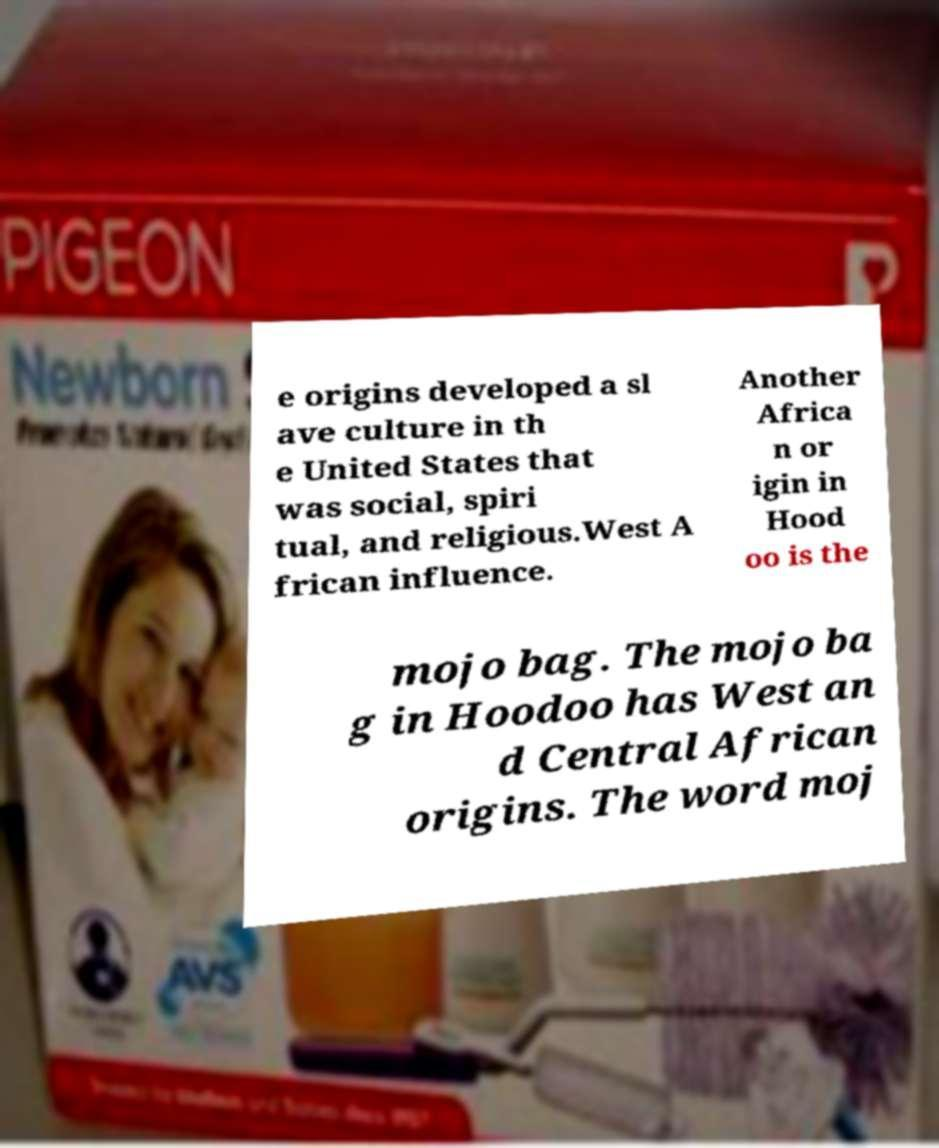For documentation purposes, I need the text within this image transcribed. Could you provide that? e origins developed a sl ave culture in th e United States that was social, spiri tual, and religious.West A frican influence. Another Africa n or igin in Hood oo is the mojo bag. The mojo ba g in Hoodoo has West an d Central African origins. The word moj 